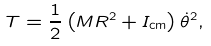Convert formula to latex. <formula><loc_0><loc_0><loc_500><loc_500>T = \frac { 1 } { 2 } \left ( M R ^ { 2 } + I _ { \text {cm} } \right ) \dot { \theta } ^ { 2 } ,</formula> 